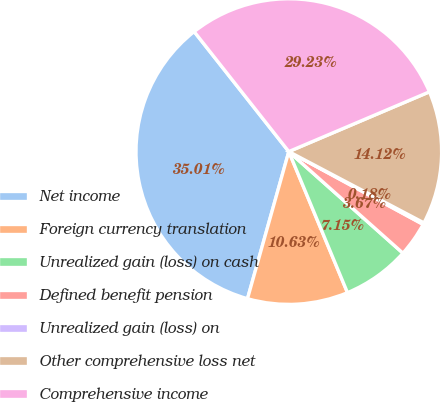<chart> <loc_0><loc_0><loc_500><loc_500><pie_chart><fcel>Net income<fcel>Foreign currency translation<fcel>Unrealized gain (loss) on cash<fcel>Defined benefit pension<fcel>Unrealized gain (loss) on<fcel>Other comprehensive loss net<fcel>Comprehensive income<nl><fcel>35.01%<fcel>10.63%<fcel>7.15%<fcel>3.67%<fcel>0.18%<fcel>14.12%<fcel>29.23%<nl></chart> 